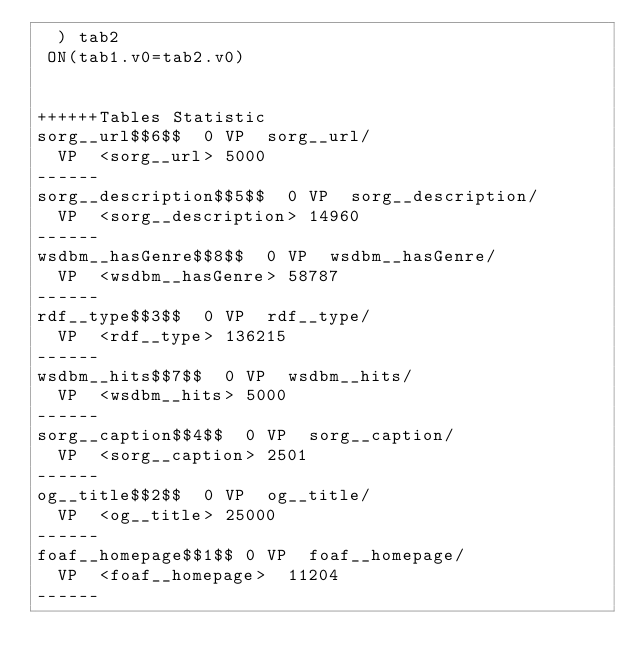Convert code to text. <code><loc_0><loc_0><loc_500><loc_500><_SQL_>	) tab2
 ON(tab1.v0=tab2.v0)


++++++Tables Statistic
sorg__url$$6$$	0	VP	sorg__url/
	VP	<sorg__url>	5000
------
sorg__description$$5$$	0	VP	sorg__description/
	VP	<sorg__description>	14960
------
wsdbm__hasGenre$$8$$	0	VP	wsdbm__hasGenre/
	VP	<wsdbm__hasGenre>	58787
------
rdf__type$$3$$	0	VP	rdf__type/
	VP	<rdf__type>	136215
------
wsdbm__hits$$7$$	0	VP	wsdbm__hits/
	VP	<wsdbm__hits>	5000
------
sorg__caption$$4$$	0	VP	sorg__caption/
	VP	<sorg__caption>	2501
------
og__title$$2$$	0	VP	og__title/
	VP	<og__title>	25000
------
foaf__homepage$$1$$	0	VP	foaf__homepage/
	VP	<foaf__homepage>	11204
------
</code> 